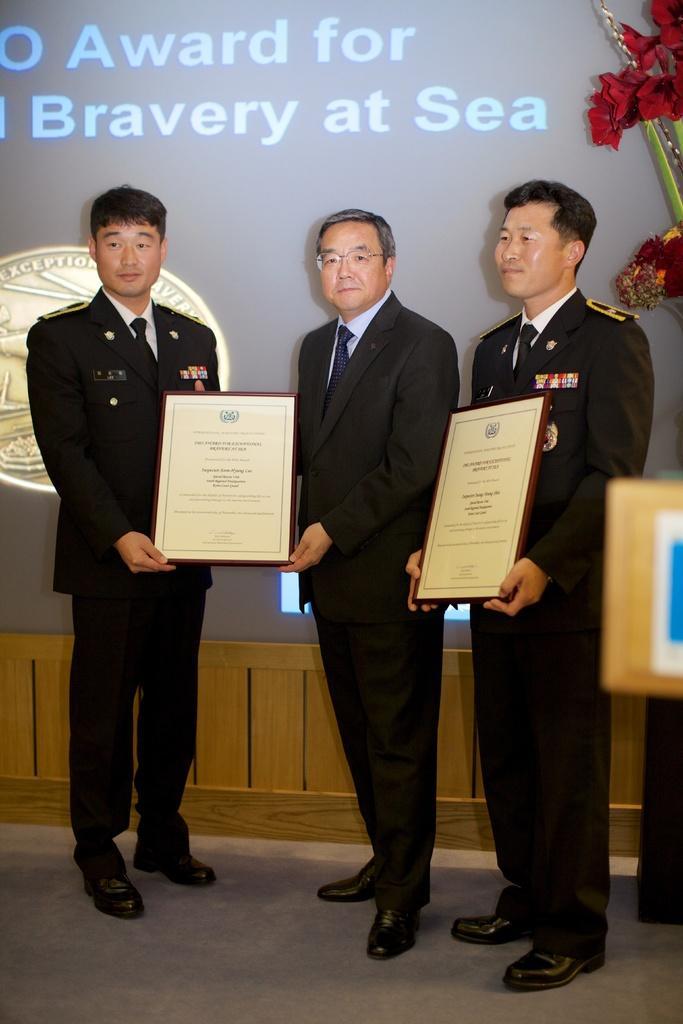In one or two sentences, can you explain what this image depicts? In this image there is a floor at the bottom. There is an object, it looks like a flower vase on the right corner. There are people holding objects in the foreground. There is a wooden object, it looks like a screen in the background. 